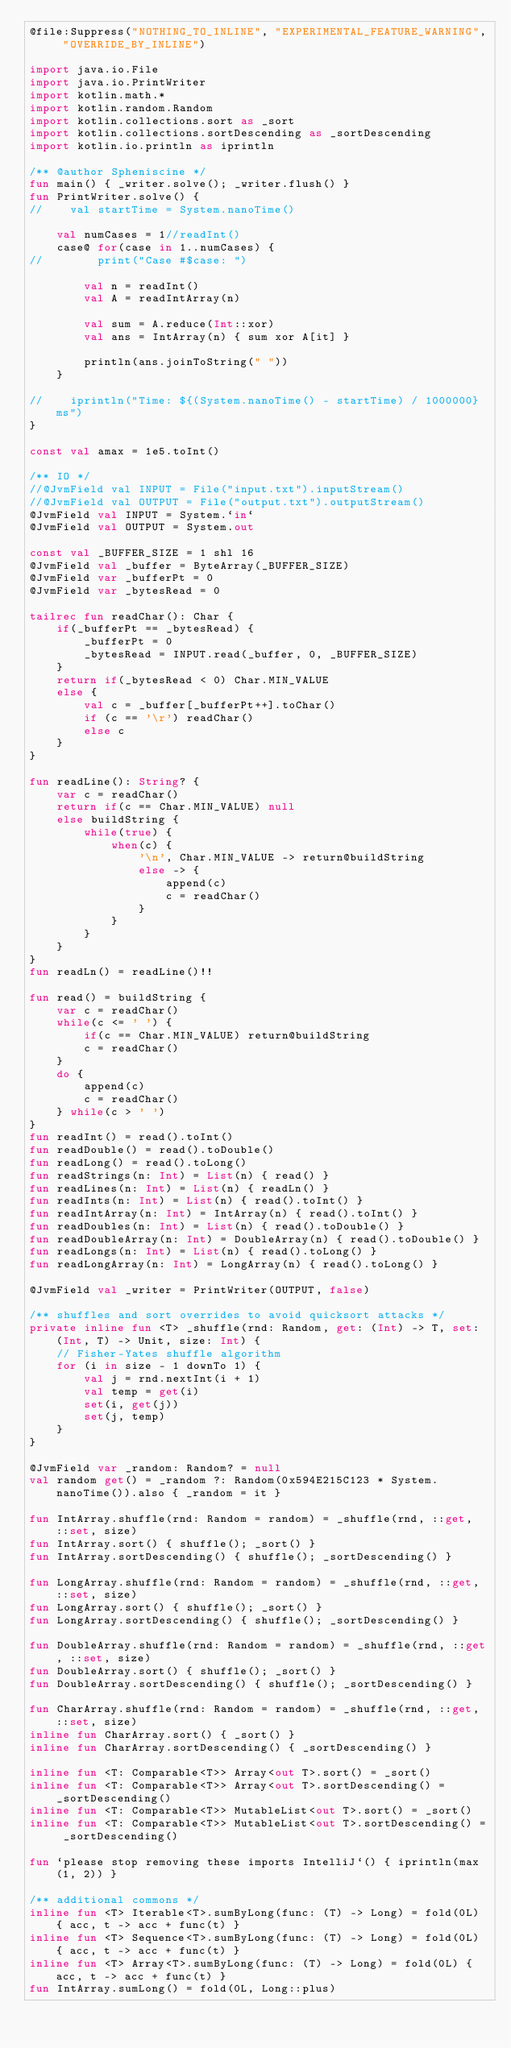Convert code to text. <code><loc_0><loc_0><loc_500><loc_500><_Kotlin_>@file:Suppress("NOTHING_TO_INLINE", "EXPERIMENTAL_FEATURE_WARNING", "OVERRIDE_BY_INLINE")

import java.io.File
import java.io.PrintWriter
import kotlin.math.*
import kotlin.random.Random
import kotlin.collections.sort as _sort
import kotlin.collections.sortDescending as _sortDescending
import kotlin.io.println as iprintln

/** @author Spheniscine */
fun main() { _writer.solve(); _writer.flush() }
fun PrintWriter.solve() {
//    val startTime = System.nanoTime()

    val numCases = 1//readInt()
    case@ for(case in 1..numCases) {
//        print("Case #$case: ")

        val n = readInt()
        val A = readIntArray(n)

        val sum = A.reduce(Int::xor)
        val ans = IntArray(n) { sum xor A[it] }

        println(ans.joinToString(" "))
    }

//    iprintln("Time: ${(System.nanoTime() - startTime) / 1000000} ms")
}

const val amax = 1e5.toInt()

/** IO */
//@JvmField val INPUT = File("input.txt").inputStream()
//@JvmField val OUTPUT = File("output.txt").outputStream()
@JvmField val INPUT = System.`in`
@JvmField val OUTPUT = System.out

const val _BUFFER_SIZE = 1 shl 16
@JvmField val _buffer = ByteArray(_BUFFER_SIZE)
@JvmField var _bufferPt = 0
@JvmField var _bytesRead = 0

tailrec fun readChar(): Char {
    if(_bufferPt == _bytesRead) {
        _bufferPt = 0
        _bytesRead = INPUT.read(_buffer, 0, _BUFFER_SIZE)
    }
    return if(_bytesRead < 0) Char.MIN_VALUE
    else {
        val c = _buffer[_bufferPt++].toChar()
        if (c == '\r') readChar()
        else c
    }
}

fun readLine(): String? {
    var c = readChar()
    return if(c == Char.MIN_VALUE) null
    else buildString {
        while(true) {
            when(c) {
                '\n', Char.MIN_VALUE -> return@buildString
                else -> {
                    append(c)
                    c = readChar()
                }
            }
        }
    }
}
fun readLn() = readLine()!!

fun read() = buildString {
    var c = readChar()
    while(c <= ' ') {
        if(c == Char.MIN_VALUE) return@buildString
        c = readChar()
    }
    do {
        append(c)
        c = readChar()
    } while(c > ' ')
}
fun readInt() = read().toInt()
fun readDouble() = read().toDouble()
fun readLong() = read().toLong()
fun readStrings(n: Int) = List(n) { read() }
fun readLines(n: Int) = List(n) { readLn() }
fun readInts(n: Int) = List(n) { read().toInt() }
fun readIntArray(n: Int) = IntArray(n) { read().toInt() }
fun readDoubles(n: Int) = List(n) { read().toDouble() }
fun readDoubleArray(n: Int) = DoubleArray(n) { read().toDouble() }
fun readLongs(n: Int) = List(n) { read().toLong() }
fun readLongArray(n: Int) = LongArray(n) { read().toLong() }

@JvmField val _writer = PrintWriter(OUTPUT, false)

/** shuffles and sort overrides to avoid quicksort attacks */
private inline fun <T> _shuffle(rnd: Random, get: (Int) -> T, set: (Int, T) -> Unit, size: Int) {
    // Fisher-Yates shuffle algorithm
    for (i in size - 1 downTo 1) {
        val j = rnd.nextInt(i + 1)
        val temp = get(i)
        set(i, get(j))
        set(j, temp)
    }
}

@JvmField var _random: Random? = null
val random get() = _random ?: Random(0x594E215C123 * System.nanoTime()).also { _random = it }

fun IntArray.shuffle(rnd: Random = random) = _shuffle(rnd, ::get, ::set, size)
fun IntArray.sort() { shuffle(); _sort() }
fun IntArray.sortDescending() { shuffle(); _sortDescending() }

fun LongArray.shuffle(rnd: Random = random) = _shuffle(rnd, ::get, ::set, size)
fun LongArray.sort() { shuffle(); _sort() }
fun LongArray.sortDescending() { shuffle(); _sortDescending() }

fun DoubleArray.shuffle(rnd: Random = random) = _shuffle(rnd, ::get, ::set, size)
fun DoubleArray.sort() { shuffle(); _sort() }
fun DoubleArray.sortDescending() { shuffle(); _sortDescending() }

fun CharArray.shuffle(rnd: Random = random) = _shuffle(rnd, ::get, ::set, size)
inline fun CharArray.sort() { _sort() }
inline fun CharArray.sortDescending() { _sortDescending() }

inline fun <T: Comparable<T>> Array<out T>.sort() = _sort()
inline fun <T: Comparable<T>> Array<out T>.sortDescending() = _sortDescending()
inline fun <T: Comparable<T>> MutableList<out T>.sort() = _sort()
inline fun <T: Comparable<T>> MutableList<out T>.sortDescending() = _sortDescending()

fun `please stop removing these imports IntelliJ`() { iprintln(max(1, 2)) }

/** additional commons */
inline fun <T> Iterable<T>.sumByLong(func: (T) -> Long) = fold(0L) { acc, t -> acc + func(t) }
inline fun <T> Sequence<T>.sumByLong(func: (T) -> Long) = fold(0L) { acc, t -> acc + func(t) }
inline fun <T> Array<T>.sumByLong(func: (T) -> Long) = fold(0L) { acc, t -> acc + func(t) }
fun IntArray.sumLong() = fold(0L, Long::plus)
</code> 